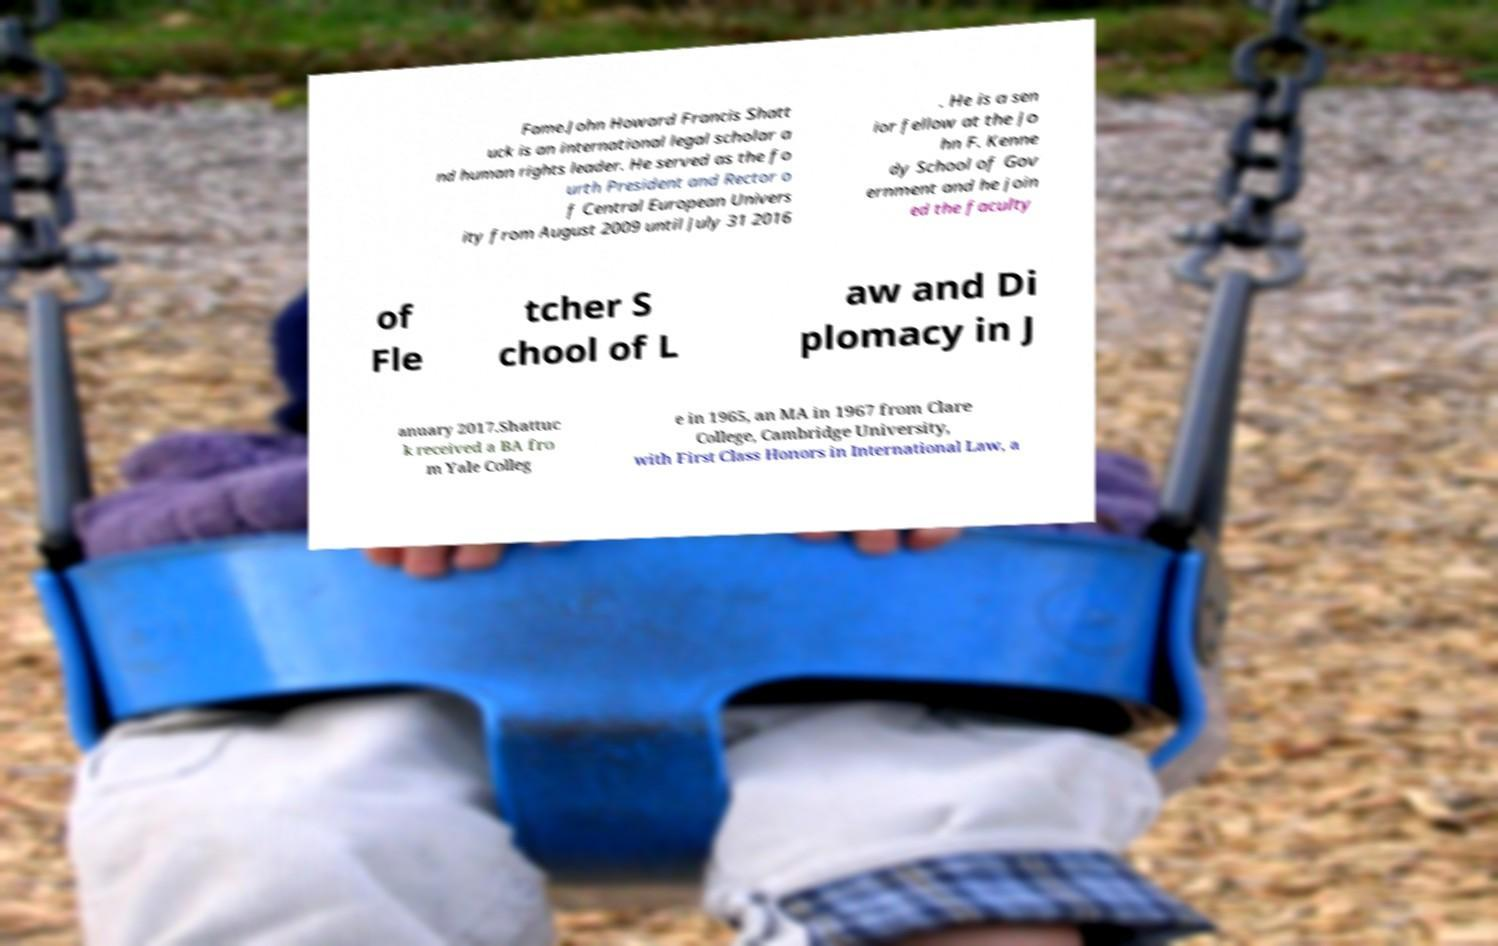I need the written content from this picture converted into text. Can you do that? Fame.John Howard Francis Shatt uck is an international legal scholar a nd human rights leader. He served as the fo urth President and Rector o f Central European Univers ity from August 2009 until July 31 2016 . He is a sen ior fellow at the Jo hn F. Kenne dy School of Gov ernment and he join ed the faculty of Fle tcher S chool of L aw and Di plomacy in J anuary 2017.Shattuc k received a BA fro m Yale Colleg e in 1965, an MA in 1967 from Clare College, Cambridge University, with First Class Honors in International Law, a 